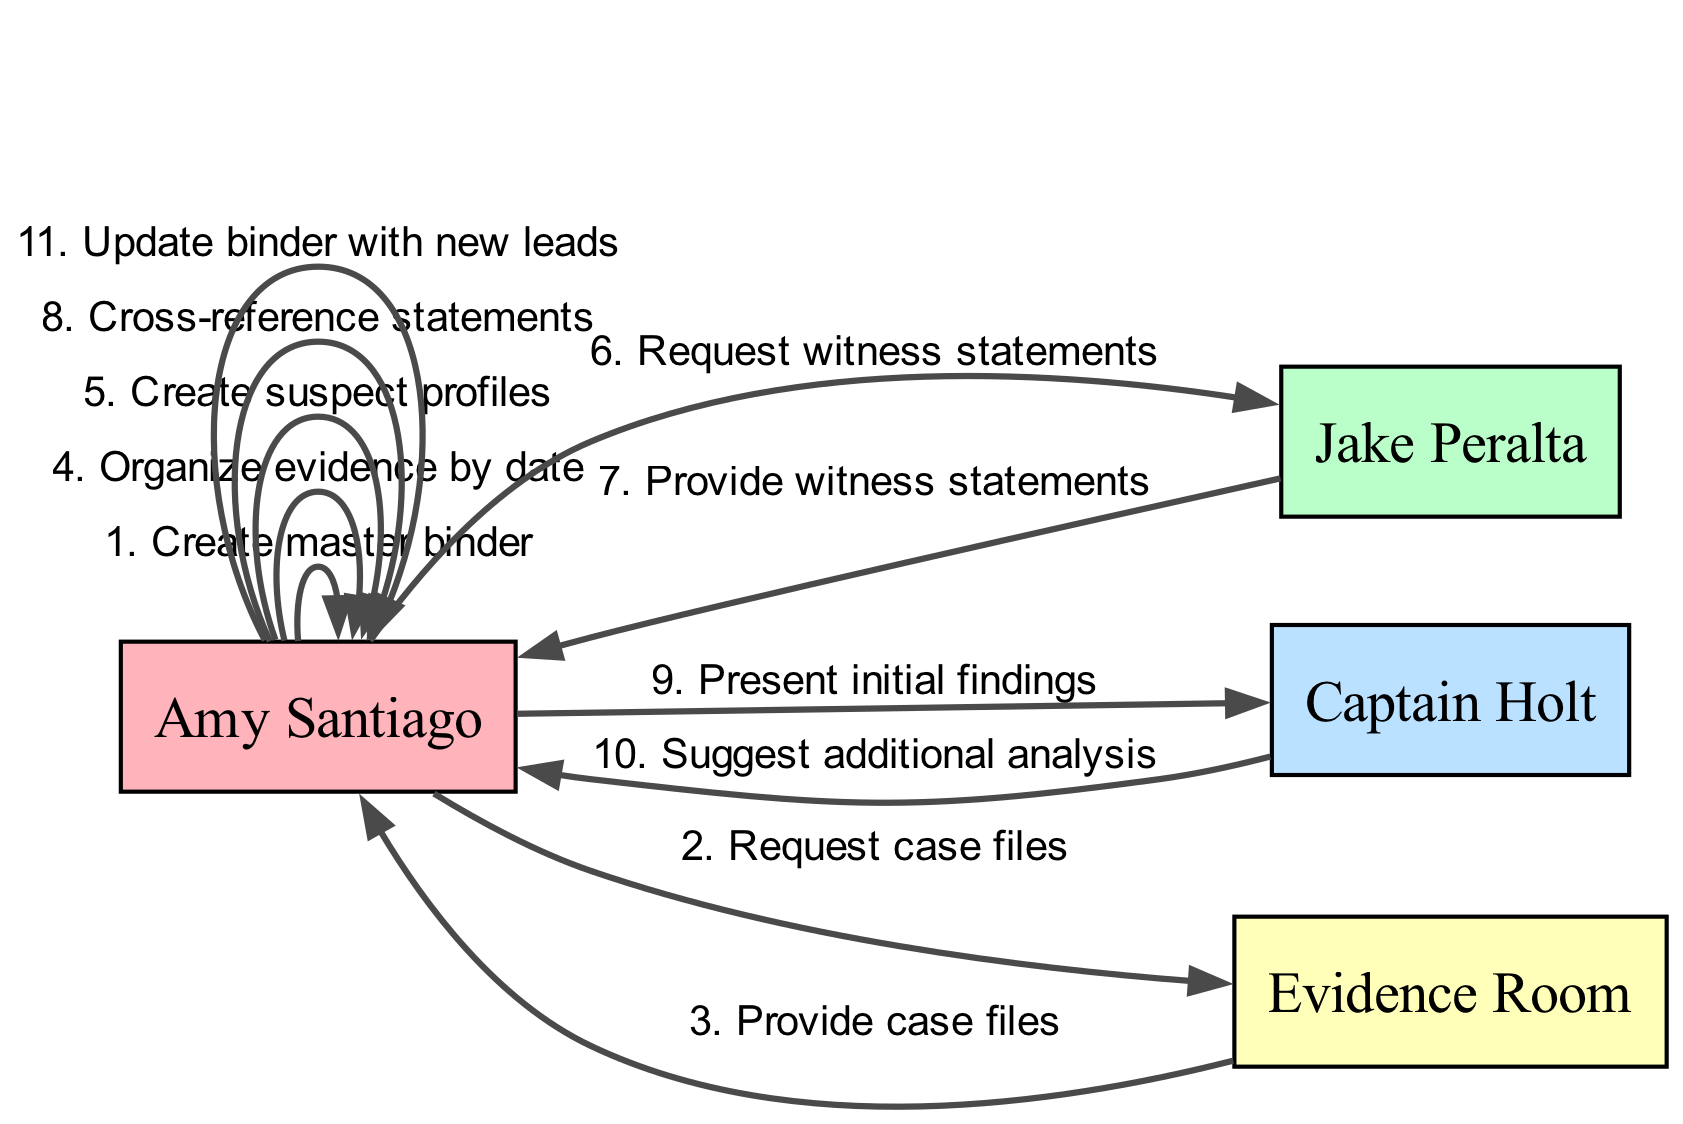What is the first action performed by Amy Santiago? The diagram indicates that the first action in the sequence is performed by Amy Santiago who creates the master binder. This is the initial step and it highlights her proactive approach to organizing.
Answer: Create master binder How many total actions are performed in the sequence? To find the total actions, we count the entries in the sequence list. There are ten actions listed, thus the total is ten.
Answer: 10 Which actor requests witness statements? The sequence shows that Amy Santiago is the one who requests witness statements from Jake Peralta, demonstrating her collaborative approach.
Answer: Amy Santiago What does Captain Holt suggest after Amy presents her findings? The diagram indicates that after Amy Santiago presents her initial findings, Captain Holt suggests conducting additional analysis, emphasizing the need for thoroughness.
Answer: Suggest additional analysis Who provides witness statements to Amy Santiago? In the sequence, it is clear that Jake Peralta provides witness statements to Amy Santiago, highlighting their teamwork in solving the case.
Answer: Jake Peralta What is the last action in the sequence performed by Amy Santiago? According to the sequence, Amy Santiago's final action is updating the binder with new leads, which signifies her ongoing effort to refine the investigation.
Answer: Update binder with new leads How many different actors are present in the diagram? The diagram lists four distinct actors involved in the sequence: Amy Santiago, Jake Peralta, Captain Holt, and the Evidence Room. By counting them, we determine that there are four actors.
Answer: 4 What specific action does Amy take after receiving the case files? After receiving the case files from the Evidence Room, Amy Santiago organizes the evidence by date, which showcases her systematic approach to the case.
Answer: Organize evidence by date Which actions involve the Evidence Room? The Evidence Room is involved in two actions: first, by providing case files to Amy Santiago and later by receiving a request from Amy. These interactions highlight its critical role in the investigation process.
Answer: Request case files, Provide case files 